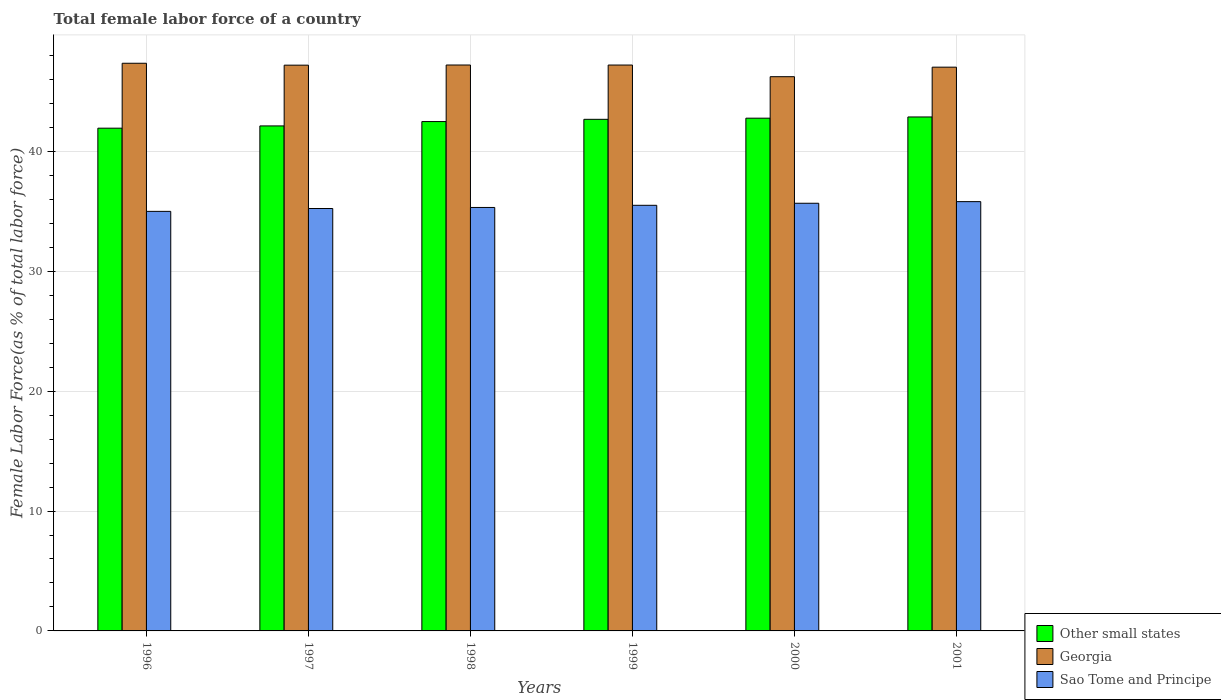Are the number of bars per tick equal to the number of legend labels?
Give a very brief answer. Yes. Are the number of bars on each tick of the X-axis equal?
Your response must be concise. Yes. How many bars are there on the 1st tick from the right?
Offer a very short reply. 3. What is the label of the 6th group of bars from the left?
Give a very brief answer. 2001. In how many cases, is the number of bars for a given year not equal to the number of legend labels?
Provide a short and direct response. 0. What is the percentage of female labor force in Sao Tome and Principe in 1997?
Offer a very short reply. 35.23. Across all years, what is the maximum percentage of female labor force in Sao Tome and Principe?
Your answer should be very brief. 35.81. Across all years, what is the minimum percentage of female labor force in Sao Tome and Principe?
Offer a very short reply. 34.99. In which year was the percentage of female labor force in Georgia minimum?
Offer a very short reply. 2000. What is the total percentage of female labor force in Sao Tome and Principe in the graph?
Your answer should be compact. 212.53. What is the difference between the percentage of female labor force in Georgia in 1996 and that in 2000?
Your answer should be compact. 1.12. What is the difference between the percentage of female labor force in Sao Tome and Principe in 2000 and the percentage of female labor force in Other small states in 1999?
Provide a short and direct response. -7. What is the average percentage of female labor force in Other small states per year?
Offer a terse response. 42.48. In the year 1998, what is the difference between the percentage of female labor force in Other small states and percentage of female labor force in Sao Tome and Principe?
Your response must be concise. 7.16. What is the ratio of the percentage of female labor force in Georgia in 2000 to that in 2001?
Offer a terse response. 0.98. Is the percentage of female labor force in Georgia in 1998 less than that in 2000?
Keep it short and to the point. No. Is the difference between the percentage of female labor force in Other small states in 1999 and 2001 greater than the difference between the percentage of female labor force in Sao Tome and Principe in 1999 and 2001?
Make the answer very short. Yes. What is the difference between the highest and the second highest percentage of female labor force in Other small states?
Make the answer very short. 0.1. What is the difference between the highest and the lowest percentage of female labor force in Sao Tome and Principe?
Make the answer very short. 0.81. Is the sum of the percentage of female labor force in Other small states in 1998 and 1999 greater than the maximum percentage of female labor force in Sao Tome and Principe across all years?
Offer a terse response. Yes. What does the 1st bar from the left in 1998 represents?
Your answer should be very brief. Other small states. What does the 2nd bar from the right in 2001 represents?
Make the answer very short. Georgia. Is it the case that in every year, the sum of the percentage of female labor force in Sao Tome and Principe and percentage of female labor force in Other small states is greater than the percentage of female labor force in Georgia?
Provide a succinct answer. Yes. How many years are there in the graph?
Your answer should be very brief. 6. What is the difference between two consecutive major ticks on the Y-axis?
Offer a very short reply. 10. Does the graph contain any zero values?
Offer a terse response. No. How many legend labels are there?
Ensure brevity in your answer.  3. How are the legend labels stacked?
Offer a terse response. Vertical. What is the title of the graph?
Make the answer very short. Total female labor force of a country. Does "Lesotho" appear as one of the legend labels in the graph?
Your response must be concise. No. What is the label or title of the Y-axis?
Provide a succinct answer. Female Labor Force(as % of total labor force). What is the Female Labor Force(as % of total labor force) of Other small states in 1996?
Give a very brief answer. 41.93. What is the Female Labor Force(as % of total labor force) in Georgia in 1996?
Your answer should be very brief. 47.35. What is the Female Labor Force(as % of total labor force) in Sao Tome and Principe in 1996?
Offer a terse response. 34.99. What is the Female Labor Force(as % of total labor force) in Other small states in 1997?
Keep it short and to the point. 42.12. What is the Female Labor Force(as % of total labor force) in Georgia in 1997?
Ensure brevity in your answer.  47.19. What is the Female Labor Force(as % of total labor force) of Sao Tome and Principe in 1997?
Keep it short and to the point. 35.23. What is the Female Labor Force(as % of total labor force) in Other small states in 1998?
Give a very brief answer. 42.49. What is the Female Labor Force(as % of total labor force) in Georgia in 1998?
Offer a terse response. 47.2. What is the Female Labor Force(as % of total labor force) in Sao Tome and Principe in 1998?
Your response must be concise. 35.32. What is the Female Labor Force(as % of total labor force) of Other small states in 1999?
Give a very brief answer. 42.67. What is the Female Labor Force(as % of total labor force) in Georgia in 1999?
Provide a succinct answer. 47.2. What is the Female Labor Force(as % of total labor force) in Sao Tome and Principe in 1999?
Your answer should be very brief. 35.5. What is the Female Labor Force(as % of total labor force) of Other small states in 2000?
Offer a very short reply. 42.77. What is the Female Labor Force(as % of total labor force) of Georgia in 2000?
Offer a terse response. 46.23. What is the Female Labor Force(as % of total labor force) of Sao Tome and Principe in 2000?
Your answer should be compact. 35.67. What is the Female Labor Force(as % of total labor force) of Other small states in 2001?
Keep it short and to the point. 42.87. What is the Female Labor Force(as % of total labor force) in Georgia in 2001?
Your answer should be compact. 47.02. What is the Female Labor Force(as % of total labor force) in Sao Tome and Principe in 2001?
Keep it short and to the point. 35.81. Across all years, what is the maximum Female Labor Force(as % of total labor force) in Other small states?
Offer a terse response. 42.87. Across all years, what is the maximum Female Labor Force(as % of total labor force) of Georgia?
Offer a terse response. 47.35. Across all years, what is the maximum Female Labor Force(as % of total labor force) in Sao Tome and Principe?
Make the answer very short. 35.81. Across all years, what is the minimum Female Labor Force(as % of total labor force) of Other small states?
Ensure brevity in your answer.  41.93. Across all years, what is the minimum Female Labor Force(as % of total labor force) of Georgia?
Your answer should be very brief. 46.23. Across all years, what is the minimum Female Labor Force(as % of total labor force) of Sao Tome and Principe?
Your answer should be very brief. 34.99. What is the total Female Labor Force(as % of total labor force) in Other small states in the graph?
Offer a very short reply. 254.85. What is the total Female Labor Force(as % of total labor force) of Georgia in the graph?
Offer a very short reply. 282.2. What is the total Female Labor Force(as % of total labor force) in Sao Tome and Principe in the graph?
Your response must be concise. 212.53. What is the difference between the Female Labor Force(as % of total labor force) in Other small states in 1996 and that in 1997?
Keep it short and to the point. -0.19. What is the difference between the Female Labor Force(as % of total labor force) in Georgia in 1996 and that in 1997?
Provide a succinct answer. 0.16. What is the difference between the Female Labor Force(as % of total labor force) in Sao Tome and Principe in 1996 and that in 1997?
Provide a succinct answer. -0.24. What is the difference between the Female Labor Force(as % of total labor force) of Other small states in 1996 and that in 1998?
Keep it short and to the point. -0.55. What is the difference between the Female Labor Force(as % of total labor force) in Georgia in 1996 and that in 1998?
Provide a short and direct response. 0.15. What is the difference between the Female Labor Force(as % of total labor force) in Sao Tome and Principe in 1996 and that in 1998?
Your response must be concise. -0.33. What is the difference between the Female Labor Force(as % of total labor force) in Other small states in 1996 and that in 1999?
Offer a very short reply. -0.74. What is the difference between the Female Labor Force(as % of total labor force) in Georgia in 1996 and that in 1999?
Make the answer very short. 0.15. What is the difference between the Female Labor Force(as % of total labor force) of Sao Tome and Principe in 1996 and that in 1999?
Your answer should be very brief. -0.51. What is the difference between the Female Labor Force(as % of total labor force) in Other small states in 1996 and that in 2000?
Keep it short and to the point. -0.83. What is the difference between the Female Labor Force(as % of total labor force) in Georgia in 1996 and that in 2000?
Make the answer very short. 1.12. What is the difference between the Female Labor Force(as % of total labor force) in Sao Tome and Principe in 1996 and that in 2000?
Your response must be concise. -0.68. What is the difference between the Female Labor Force(as % of total labor force) in Other small states in 1996 and that in 2001?
Provide a short and direct response. -0.94. What is the difference between the Female Labor Force(as % of total labor force) of Georgia in 1996 and that in 2001?
Ensure brevity in your answer.  0.33. What is the difference between the Female Labor Force(as % of total labor force) in Sao Tome and Principe in 1996 and that in 2001?
Offer a very short reply. -0.81. What is the difference between the Female Labor Force(as % of total labor force) in Other small states in 1997 and that in 1998?
Give a very brief answer. -0.36. What is the difference between the Female Labor Force(as % of total labor force) in Georgia in 1997 and that in 1998?
Provide a succinct answer. -0.01. What is the difference between the Female Labor Force(as % of total labor force) in Sao Tome and Principe in 1997 and that in 1998?
Offer a terse response. -0.09. What is the difference between the Female Labor Force(as % of total labor force) of Other small states in 1997 and that in 1999?
Make the answer very short. -0.55. What is the difference between the Female Labor Force(as % of total labor force) in Georgia in 1997 and that in 1999?
Give a very brief answer. -0.01. What is the difference between the Female Labor Force(as % of total labor force) in Sao Tome and Principe in 1997 and that in 1999?
Provide a succinct answer. -0.27. What is the difference between the Female Labor Force(as % of total labor force) of Other small states in 1997 and that in 2000?
Offer a very short reply. -0.65. What is the difference between the Female Labor Force(as % of total labor force) in Georgia in 1997 and that in 2000?
Keep it short and to the point. 0.96. What is the difference between the Female Labor Force(as % of total labor force) of Sao Tome and Principe in 1997 and that in 2000?
Offer a terse response. -0.44. What is the difference between the Female Labor Force(as % of total labor force) of Other small states in 1997 and that in 2001?
Give a very brief answer. -0.75. What is the difference between the Female Labor Force(as % of total labor force) in Georgia in 1997 and that in 2001?
Your answer should be compact. 0.17. What is the difference between the Female Labor Force(as % of total labor force) in Sao Tome and Principe in 1997 and that in 2001?
Your response must be concise. -0.57. What is the difference between the Female Labor Force(as % of total labor force) of Other small states in 1998 and that in 1999?
Your answer should be compact. -0.19. What is the difference between the Female Labor Force(as % of total labor force) of Georgia in 1998 and that in 1999?
Your answer should be compact. 0. What is the difference between the Female Labor Force(as % of total labor force) of Sao Tome and Principe in 1998 and that in 1999?
Your answer should be very brief. -0.18. What is the difference between the Female Labor Force(as % of total labor force) in Other small states in 1998 and that in 2000?
Ensure brevity in your answer.  -0.28. What is the difference between the Female Labor Force(as % of total labor force) of Georgia in 1998 and that in 2000?
Your response must be concise. 0.97. What is the difference between the Female Labor Force(as % of total labor force) of Sao Tome and Principe in 1998 and that in 2000?
Provide a succinct answer. -0.35. What is the difference between the Female Labor Force(as % of total labor force) of Other small states in 1998 and that in 2001?
Give a very brief answer. -0.39. What is the difference between the Female Labor Force(as % of total labor force) of Georgia in 1998 and that in 2001?
Your answer should be compact. 0.18. What is the difference between the Female Labor Force(as % of total labor force) in Sao Tome and Principe in 1998 and that in 2001?
Give a very brief answer. -0.49. What is the difference between the Female Labor Force(as % of total labor force) in Other small states in 1999 and that in 2000?
Offer a very short reply. -0.1. What is the difference between the Female Labor Force(as % of total labor force) in Georgia in 1999 and that in 2000?
Offer a terse response. 0.97. What is the difference between the Female Labor Force(as % of total labor force) of Sao Tome and Principe in 1999 and that in 2000?
Keep it short and to the point. -0.17. What is the difference between the Female Labor Force(as % of total labor force) in Other small states in 1999 and that in 2001?
Your answer should be very brief. -0.2. What is the difference between the Female Labor Force(as % of total labor force) in Georgia in 1999 and that in 2001?
Offer a terse response. 0.18. What is the difference between the Female Labor Force(as % of total labor force) of Sao Tome and Principe in 1999 and that in 2001?
Keep it short and to the point. -0.31. What is the difference between the Female Labor Force(as % of total labor force) of Other small states in 2000 and that in 2001?
Give a very brief answer. -0.1. What is the difference between the Female Labor Force(as % of total labor force) in Georgia in 2000 and that in 2001?
Keep it short and to the point. -0.79. What is the difference between the Female Labor Force(as % of total labor force) in Sao Tome and Principe in 2000 and that in 2001?
Your answer should be very brief. -0.14. What is the difference between the Female Labor Force(as % of total labor force) in Other small states in 1996 and the Female Labor Force(as % of total labor force) in Georgia in 1997?
Ensure brevity in your answer.  -5.26. What is the difference between the Female Labor Force(as % of total labor force) in Other small states in 1996 and the Female Labor Force(as % of total labor force) in Sao Tome and Principe in 1997?
Your answer should be very brief. 6.7. What is the difference between the Female Labor Force(as % of total labor force) of Georgia in 1996 and the Female Labor Force(as % of total labor force) of Sao Tome and Principe in 1997?
Provide a short and direct response. 12.11. What is the difference between the Female Labor Force(as % of total labor force) of Other small states in 1996 and the Female Labor Force(as % of total labor force) of Georgia in 1998?
Provide a succinct answer. -5.27. What is the difference between the Female Labor Force(as % of total labor force) of Other small states in 1996 and the Female Labor Force(as % of total labor force) of Sao Tome and Principe in 1998?
Make the answer very short. 6.61. What is the difference between the Female Labor Force(as % of total labor force) in Georgia in 1996 and the Female Labor Force(as % of total labor force) in Sao Tome and Principe in 1998?
Offer a very short reply. 12.03. What is the difference between the Female Labor Force(as % of total labor force) of Other small states in 1996 and the Female Labor Force(as % of total labor force) of Georgia in 1999?
Keep it short and to the point. -5.27. What is the difference between the Female Labor Force(as % of total labor force) of Other small states in 1996 and the Female Labor Force(as % of total labor force) of Sao Tome and Principe in 1999?
Offer a terse response. 6.43. What is the difference between the Female Labor Force(as % of total labor force) of Georgia in 1996 and the Female Labor Force(as % of total labor force) of Sao Tome and Principe in 1999?
Your response must be concise. 11.85. What is the difference between the Female Labor Force(as % of total labor force) in Other small states in 1996 and the Female Labor Force(as % of total labor force) in Georgia in 2000?
Your response must be concise. -4.3. What is the difference between the Female Labor Force(as % of total labor force) in Other small states in 1996 and the Female Labor Force(as % of total labor force) in Sao Tome and Principe in 2000?
Your answer should be very brief. 6.26. What is the difference between the Female Labor Force(as % of total labor force) of Georgia in 1996 and the Female Labor Force(as % of total labor force) of Sao Tome and Principe in 2000?
Ensure brevity in your answer.  11.68. What is the difference between the Female Labor Force(as % of total labor force) of Other small states in 1996 and the Female Labor Force(as % of total labor force) of Georgia in 2001?
Offer a terse response. -5.09. What is the difference between the Female Labor Force(as % of total labor force) in Other small states in 1996 and the Female Labor Force(as % of total labor force) in Sao Tome and Principe in 2001?
Your answer should be very brief. 6.13. What is the difference between the Female Labor Force(as % of total labor force) in Georgia in 1996 and the Female Labor Force(as % of total labor force) in Sao Tome and Principe in 2001?
Offer a very short reply. 11.54. What is the difference between the Female Labor Force(as % of total labor force) in Other small states in 1997 and the Female Labor Force(as % of total labor force) in Georgia in 1998?
Offer a very short reply. -5.08. What is the difference between the Female Labor Force(as % of total labor force) in Other small states in 1997 and the Female Labor Force(as % of total labor force) in Sao Tome and Principe in 1998?
Your answer should be compact. 6.8. What is the difference between the Female Labor Force(as % of total labor force) of Georgia in 1997 and the Female Labor Force(as % of total labor force) of Sao Tome and Principe in 1998?
Provide a succinct answer. 11.87. What is the difference between the Female Labor Force(as % of total labor force) of Other small states in 1997 and the Female Labor Force(as % of total labor force) of Georgia in 1999?
Give a very brief answer. -5.08. What is the difference between the Female Labor Force(as % of total labor force) of Other small states in 1997 and the Female Labor Force(as % of total labor force) of Sao Tome and Principe in 1999?
Your answer should be compact. 6.62. What is the difference between the Female Labor Force(as % of total labor force) of Georgia in 1997 and the Female Labor Force(as % of total labor force) of Sao Tome and Principe in 1999?
Your response must be concise. 11.69. What is the difference between the Female Labor Force(as % of total labor force) in Other small states in 1997 and the Female Labor Force(as % of total labor force) in Georgia in 2000?
Offer a terse response. -4.11. What is the difference between the Female Labor Force(as % of total labor force) of Other small states in 1997 and the Female Labor Force(as % of total labor force) of Sao Tome and Principe in 2000?
Give a very brief answer. 6.45. What is the difference between the Female Labor Force(as % of total labor force) of Georgia in 1997 and the Female Labor Force(as % of total labor force) of Sao Tome and Principe in 2000?
Provide a succinct answer. 11.52. What is the difference between the Female Labor Force(as % of total labor force) in Other small states in 1997 and the Female Labor Force(as % of total labor force) in Georgia in 2001?
Your response must be concise. -4.9. What is the difference between the Female Labor Force(as % of total labor force) of Other small states in 1997 and the Female Labor Force(as % of total labor force) of Sao Tome and Principe in 2001?
Your answer should be very brief. 6.32. What is the difference between the Female Labor Force(as % of total labor force) in Georgia in 1997 and the Female Labor Force(as % of total labor force) in Sao Tome and Principe in 2001?
Your response must be concise. 11.38. What is the difference between the Female Labor Force(as % of total labor force) in Other small states in 1998 and the Female Labor Force(as % of total labor force) in Georgia in 1999?
Offer a terse response. -4.72. What is the difference between the Female Labor Force(as % of total labor force) in Other small states in 1998 and the Female Labor Force(as % of total labor force) in Sao Tome and Principe in 1999?
Ensure brevity in your answer.  6.98. What is the difference between the Female Labor Force(as % of total labor force) in Georgia in 1998 and the Female Labor Force(as % of total labor force) in Sao Tome and Principe in 1999?
Offer a very short reply. 11.7. What is the difference between the Female Labor Force(as % of total labor force) in Other small states in 1998 and the Female Labor Force(as % of total labor force) in Georgia in 2000?
Make the answer very short. -3.74. What is the difference between the Female Labor Force(as % of total labor force) in Other small states in 1998 and the Female Labor Force(as % of total labor force) in Sao Tome and Principe in 2000?
Keep it short and to the point. 6.81. What is the difference between the Female Labor Force(as % of total labor force) in Georgia in 1998 and the Female Labor Force(as % of total labor force) in Sao Tome and Principe in 2000?
Keep it short and to the point. 11.53. What is the difference between the Female Labor Force(as % of total labor force) in Other small states in 1998 and the Female Labor Force(as % of total labor force) in Georgia in 2001?
Offer a terse response. -4.54. What is the difference between the Female Labor Force(as % of total labor force) of Other small states in 1998 and the Female Labor Force(as % of total labor force) of Sao Tome and Principe in 2001?
Offer a terse response. 6.68. What is the difference between the Female Labor Force(as % of total labor force) of Georgia in 1998 and the Female Labor Force(as % of total labor force) of Sao Tome and Principe in 2001?
Keep it short and to the point. 11.4. What is the difference between the Female Labor Force(as % of total labor force) of Other small states in 1999 and the Female Labor Force(as % of total labor force) of Georgia in 2000?
Keep it short and to the point. -3.56. What is the difference between the Female Labor Force(as % of total labor force) in Other small states in 1999 and the Female Labor Force(as % of total labor force) in Sao Tome and Principe in 2000?
Keep it short and to the point. 7. What is the difference between the Female Labor Force(as % of total labor force) in Georgia in 1999 and the Female Labor Force(as % of total labor force) in Sao Tome and Principe in 2000?
Give a very brief answer. 11.53. What is the difference between the Female Labor Force(as % of total labor force) in Other small states in 1999 and the Female Labor Force(as % of total labor force) in Georgia in 2001?
Offer a terse response. -4.35. What is the difference between the Female Labor Force(as % of total labor force) of Other small states in 1999 and the Female Labor Force(as % of total labor force) of Sao Tome and Principe in 2001?
Your answer should be very brief. 6.87. What is the difference between the Female Labor Force(as % of total labor force) of Georgia in 1999 and the Female Labor Force(as % of total labor force) of Sao Tome and Principe in 2001?
Give a very brief answer. 11.39. What is the difference between the Female Labor Force(as % of total labor force) in Other small states in 2000 and the Female Labor Force(as % of total labor force) in Georgia in 2001?
Ensure brevity in your answer.  -4.26. What is the difference between the Female Labor Force(as % of total labor force) in Other small states in 2000 and the Female Labor Force(as % of total labor force) in Sao Tome and Principe in 2001?
Your answer should be compact. 6.96. What is the difference between the Female Labor Force(as % of total labor force) of Georgia in 2000 and the Female Labor Force(as % of total labor force) of Sao Tome and Principe in 2001?
Offer a terse response. 10.42. What is the average Female Labor Force(as % of total labor force) in Other small states per year?
Your answer should be compact. 42.48. What is the average Female Labor Force(as % of total labor force) in Georgia per year?
Provide a short and direct response. 47.03. What is the average Female Labor Force(as % of total labor force) in Sao Tome and Principe per year?
Give a very brief answer. 35.42. In the year 1996, what is the difference between the Female Labor Force(as % of total labor force) in Other small states and Female Labor Force(as % of total labor force) in Georgia?
Provide a succinct answer. -5.42. In the year 1996, what is the difference between the Female Labor Force(as % of total labor force) of Other small states and Female Labor Force(as % of total labor force) of Sao Tome and Principe?
Offer a terse response. 6.94. In the year 1996, what is the difference between the Female Labor Force(as % of total labor force) in Georgia and Female Labor Force(as % of total labor force) in Sao Tome and Principe?
Your answer should be very brief. 12.35. In the year 1997, what is the difference between the Female Labor Force(as % of total labor force) of Other small states and Female Labor Force(as % of total labor force) of Georgia?
Ensure brevity in your answer.  -5.07. In the year 1997, what is the difference between the Female Labor Force(as % of total labor force) of Other small states and Female Labor Force(as % of total labor force) of Sao Tome and Principe?
Give a very brief answer. 6.89. In the year 1997, what is the difference between the Female Labor Force(as % of total labor force) of Georgia and Female Labor Force(as % of total labor force) of Sao Tome and Principe?
Provide a short and direct response. 11.96. In the year 1998, what is the difference between the Female Labor Force(as % of total labor force) in Other small states and Female Labor Force(as % of total labor force) in Georgia?
Ensure brevity in your answer.  -4.72. In the year 1998, what is the difference between the Female Labor Force(as % of total labor force) of Other small states and Female Labor Force(as % of total labor force) of Sao Tome and Principe?
Your response must be concise. 7.16. In the year 1998, what is the difference between the Female Labor Force(as % of total labor force) of Georgia and Female Labor Force(as % of total labor force) of Sao Tome and Principe?
Offer a very short reply. 11.88. In the year 1999, what is the difference between the Female Labor Force(as % of total labor force) of Other small states and Female Labor Force(as % of total labor force) of Georgia?
Your response must be concise. -4.53. In the year 1999, what is the difference between the Female Labor Force(as % of total labor force) in Other small states and Female Labor Force(as % of total labor force) in Sao Tome and Principe?
Your response must be concise. 7.17. In the year 1999, what is the difference between the Female Labor Force(as % of total labor force) in Georgia and Female Labor Force(as % of total labor force) in Sao Tome and Principe?
Provide a short and direct response. 11.7. In the year 2000, what is the difference between the Female Labor Force(as % of total labor force) in Other small states and Female Labor Force(as % of total labor force) in Georgia?
Your answer should be very brief. -3.46. In the year 2000, what is the difference between the Female Labor Force(as % of total labor force) of Other small states and Female Labor Force(as % of total labor force) of Sao Tome and Principe?
Your answer should be compact. 7.1. In the year 2000, what is the difference between the Female Labor Force(as % of total labor force) in Georgia and Female Labor Force(as % of total labor force) in Sao Tome and Principe?
Offer a terse response. 10.56. In the year 2001, what is the difference between the Female Labor Force(as % of total labor force) of Other small states and Female Labor Force(as % of total labor force) of Georgia?
Give a very brief answer. -4.15. In the year 2001, what is the difference between the Female Labor Force(as % of total labor force) in Other small states and Female Labor Force(as % of total labor force) in Sao Tome and Principe?
Your response must be concise. 7.06. In the year 2001, what is the difference between the Female Labor Force(as % of total labor force) in Georgia and Female Labor Force(as % of total labor force) in Sao Tome and Principe?
Provide a succinct answer. 11.22. What is the ratio of the Female Labor Force(as % of total labor force) of Georgia in 1996 to that in 1997?
Your answer should be very brief. 1. What is the ratio of the Female Labor Force(as % of total labor force) of Sao Tome and Principe in 1996 to that in 1997?
Give a very brief answer. 0.99. What is the ratio of the Female Labor Force(as % of total labor force) in Other small states in 1996 to that in 1998?
Your answer should be compact. 0.99. What is the ratio of the Female Labor Force(as % of total labor force) of Other small states in 1996 to that in 1999?
Offer a very short reply. 0.98. What is the ratio of the Female Labor Force(as % of total labor force) in Sao Tome and Principe in 1996 to that in 1999?
Provide a succinct answer. 0.99. What is the ratio of the Female Labor Force(as % of total labor force) of Other small states in 1996 to that in 2000?
Provide a short and direct response. 0.98. What is the ratio of the Female Labor Force(as % of total labor force) in Georgia in 1996 to that in 2000?
Your answer should be very brief. 1.02. What is the ratio of the Female Labor Force(as % of total labor force) of Sao Tome and Principe in 1996 to that in 2000?
Provide a succinct answer. 0.98. What is the ratio of the Female Labor Force(as % of total labor force) in Other small states in 1996 to that in 2001?
Ensure brevity in your answer.  0.98. What is the ratio of the Female Labor Force(as % of total labor force) of Sao Tome and Principe in 1996 to that in 2001?
Make the answer very short. 0.98. What is the ratio of the Female Labor Force(as % of total labor force) in Other small states in 1997 to that in 1998?
Your response must be concise. 0.99. What is the ratio of the Female Labor Force(as % of total labor force) of Sao Tome and Principe in 1997 to that in 1998?
Provide a succinct answer. 1. What is the ratio of the Female Labor Force(as % of total labor force) in Other small states in 1997 to that in 1999?
Keep it short and to the point. 0.99. What is the ratio of the Female Labor Force(as % of total labor force) in Sao Tome and Principe in 1997 to that in 1999?
Provide a short and direct response. 0.99. What is the ratio of the Female Labor Force(as % of total labor force) in Other small states in 1997 to that in 2000?
Offer a terse response. 0.98. What is the ratio of the Female Labor Force(as % of total labor force) in Georgia in 1997 to that in 2000?
Ensure brevity in your answer.  1.02. What is the ratio of the Female Labor Force(as % of total labor force) of Other small states in 1997 to that in 2001?
Keep it short and to the point. 0.98. What is the ratio of the Female Labor Force(as % of total labor force) in Georgia in 1998 to that in 1999?
Your answer should be very brief. 1. What is the ratio of the Female Labor Force(as % of total labor force) of Sao Tome and Principe in 1998 to that in 1999?
Give a very brief answer. 0.99. What is the ratio of the Female Labor Force(as % of total labor force) in Georgia in 1998 to that in 2000?
Give a very brief answer. 1.02. What is the ratio of the Female Labor Force(as % of total labor force) of Sao Tome and Principe in 1998 to that in 2000?
Provide a succinct answer. 0.99. What is the ratio of the Female Labor Force(as % of total labor force) in Other small states in 1998 to that in 2001?
Provide a short and direct response. 0.99. What is the ratio of the Female Labor Force(as % of total labor force) in Georgia in 1998 to that in 2001?
Keep it short and to the point. 1. What is the ratio of the Female Labor Force(as % of total labor force) in Sao Tome and Principe in 1998 to that in 2001?
Ensure brevity in your answer.  0.99. What is the ratio of the Female Labor Force(as % of total labor force) in Sao Tome and Principe in 1999 to that in 2000?
Provide a succinct answer. 1. What is the ratio of the Female Labor Force(as % of total labor force) in Other small states in 1999 to that in 2001?
Your answer should be compact. 1. What is the ratio of the Female Labor Force(as % of total labor force) in Georgia in 1999 to that in 2001?
Keep it short and to the point. 1. What is the ratio of the Female Labor Force(as % of total labor force) in Georgia in 2000 to that in 2001?
Offer a terse response. 0.98. What is the difference between the highest and the second highest Female Labor Force(as % of total labor force) of Other small states?
Offer a terse response. 0.1. What is the difference between the highest and the second highest Female Labor Force(as % of total labor force) in Georgia?
Your answer should be very brief. 0.15. What is the difference between the highest and the second highest Female Labor Force(as % of total labor force) in Sao Tome and Principe?
Make the answer very short. 0.14. What is the difference between the highest and the lowest Female Labor Force(as % of total labor force) in Other small states?
Offer a very short reply. 0.94. What is the difference between the highest and the lowest Female Labor Force(as % of total labor force) in Georgia?
Your response must be concise. 1.12. What is the difference between the highest and the lowest Female Labor Force(as % of total labor force) of Sao Tome and Principe?
Offer a very short reply. 0.81. 